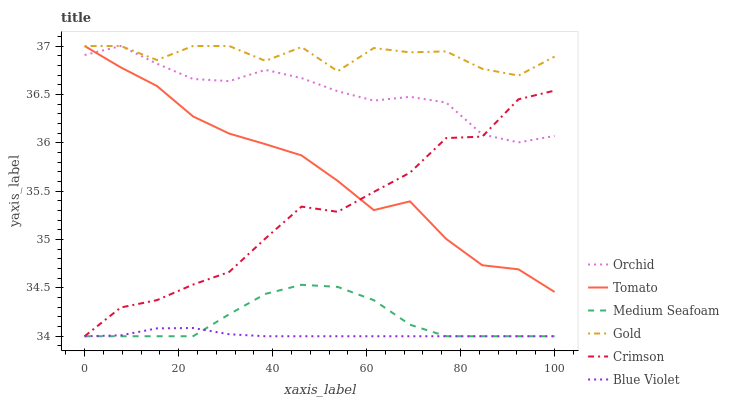Does Blue Violet have the minimum area under the curve?
Answer yes or no. Yes. Does Gold have the maximum area under the curve?
Answer yes or no. Yes. Does Crimson have the minimum area under the curve?
Answer yes or no. No. Does Crimson have the maximum area under the curve?
Answer yes or no. No. Is Blue Violet the smoothest?
Answer yes or no. Yes. Is Gold the roughest?
Answer yes or no. Yes. Is Crimson the smoothest?
Answer yes or no. No. Is Crimson the roughest?
Answer yes or no. No. Does Crimson have the lowest value?
Answer yes or no. Yes. Does Gold have the lowest value?
Answer yes or no. No. Does Orchid have the highest value?
Answer yes or no. Yes. Does Crimson have the highest value?
Answer yes or no. No. Is Medium Seafoam less than Gold?
Answer yes or no. Yes. Is Orchid greater than Blue Violet?
Answer yes or no. Yes. Does Orchid intersect Crimson?
Answer yes or no. Yes. Is Orchid less than Crimson?
Answer yes or no. No. Is Orchid greater than Crimson?
Answer yes or no. No. Does Medium Seafoam intersect Gold?
Answer yes or no. No. 